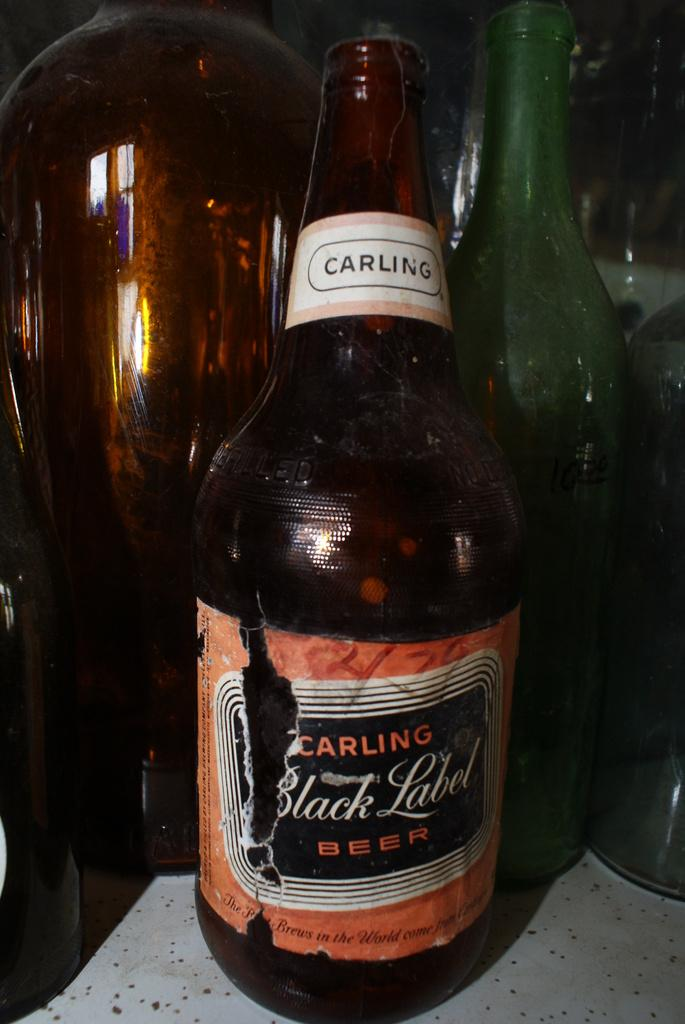<image>
Present a compact description of the photo's key features. A dark bottle of beer that is the brand carling called black label. 